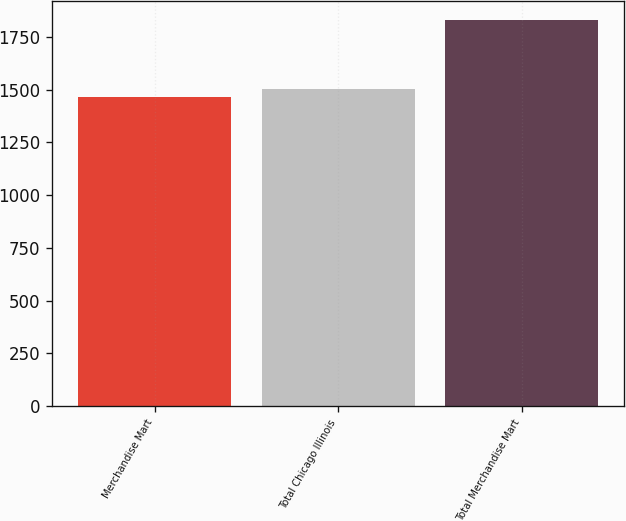Convert chart. <chart><loc_0><loc_0><loc_500><loc_500><bar_chart><fcel>Merchandise Mart<fcel>Total Chicago Illinois<fcel>Total Merchandise Mart<nl><fcel>1467<fcel>1503.3<fcel>1830<nl></chart> 